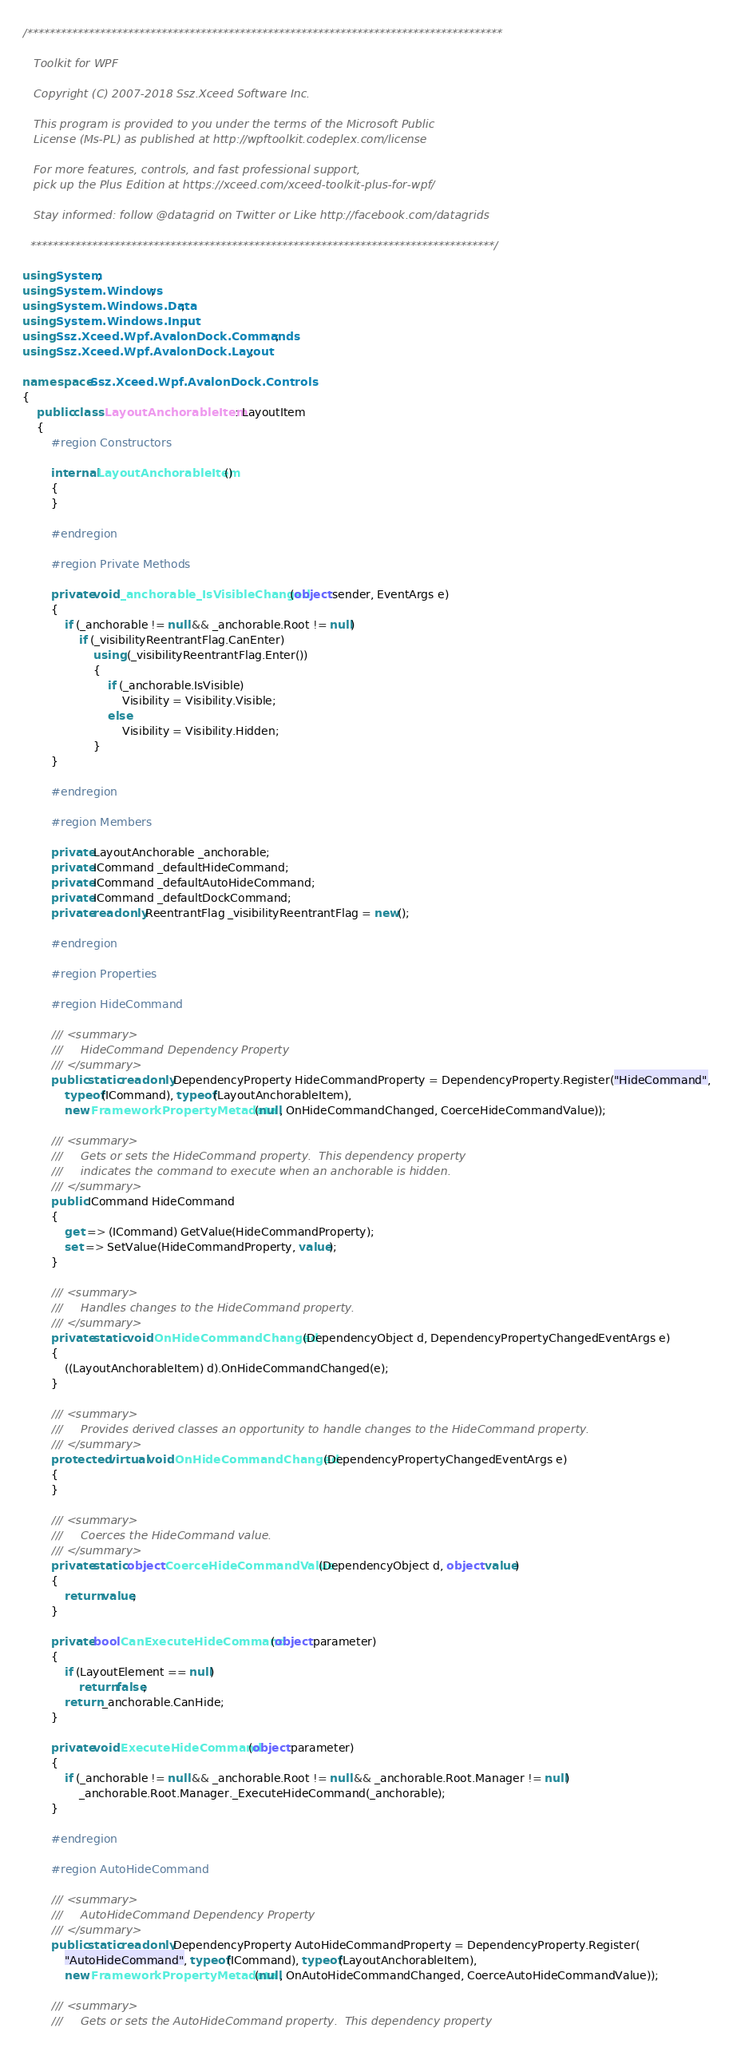Convert code to text. <code><loc_0><loc_0><loc_500><loc_500><_C#_>/*************************************************************************************
   
   Toolkit for WPF

   Copyright (C) 2007-2018 Ssz.Xceed Software Inc.

   This program is provided to you under the terms of the Microsoft Public
   License (Ms-PL) as published at http://wpftoolkit.codeplex.com/license 

   For more features, controls, and fast professional support,
   pick up the Plus Edition at https://xceed.com/xceed-toolkit-plus-for-wpf/

   Stay informed: follow @datagrid on Twitter or Like http://facebook.com/datagrids

  ***********************************************************************************/

using System;
using System.Windows;
using System.Windows.Data;
using System.Windows.Input;
using Ssz.Xceed.Wpf.AvalonDock.Commands;
using Ssz.Xceed.Wpf.AvalonDock.Layout;

namespace Ssz.Xceed.Wpf.AvalonDock.Controls
{
    public class LayoutAnchorableItem : LayoutItem
    {
        #region Constructors

        internal LayoutAnchorableItem()
        {
        }

        #endregion

        #region Private Methods

        private void _anchorable_IsVisibleChanged(object sender, EventArgs e)
        {
            if (_anchorable != null && _anchorable.Root != null)
                if (_visibilityReentrantFlag.CanEnter)
                    using (_visibilityReentrantFlag.Enter())
                    {
                        if (_anchorable.IsVisible)
                            Visibility = Visibility.Visible;
                        else
                            Visibility = Visibility.Hidden;
                    }
        }

        #endregion

        #region Members

        private LayoutAnchorable _anchorable;
        private ICommand _defaultHideCommand;
        private ICommand _defaultAutoHideCommand;
        private ICommand _defaultDockCommand;
        private readonly ReentrantFlag _visibilityReentrantFlag = new();

        #endregion

        #region Properties

        #region HideCommand

        /// <summary>
        ///     HideCommand Dependency Property
        /// </summary>
        public static readonly DependencyProperty HideCommandProperty = DependencyProperty.Register("HideCommand",
            typeof(ICommand), typeof(LayoutAnchorableItem),
            new FrameworkPropertyMetadata(null, OnHideCommandChanged, CoerceHideCommandValue));

        /// <summary>
        ///     Gets or sets the HideCommand property.  This dependency property
        ///     indicates the command to execute when an anchorable is hidden.
        /// </summary>
        public ICommand HideCommand
        {
            get => (ICommand) GetValue(HideCommandProperty);
            set => SetValue(HideCommandProperty, value);
        }

        /// <summary>
        ///     Handles changes to the HideCommand property.
        /// </summary>
        private static void OnHideCommandChanged(DependencyObject d, DependencyPropertyChangedEventArgs e)
        {
            ((LayoutAnchorableItem) d).OnHideCommandChanged(e);
        }

        /// <summary>
        ///     Provides derived classes an opportunity to handle changes to the HideCommand property.
        /// </summary>
        protected virtual void OnHideCommandChanged(DependencyPropertyChangedEventArgs e)
        {
        }

        /// <summary>
        ///     Coerces the HideCommand value.
        /// </summary>
        private static object CoerceHideCommandValue(DependencyObject d, object value)
        {
            return value;
        }

        private bool CanExecuteHideCommand(object parameter)
        {
            if (LayoutElement == null)
                return false;
            return _anchorable.CanHide;
        }

        private void ExecuteHideCommand(object parameter)
        {
            if (_anchorable != null && _anchorable.Root != null && _anchorable.Root.Manager != null)
                _anchorable.Root.Manager._ExecuteHideCommand(_anchorable);
        }

        #endregion

        #region AutoHideCommand

        /// <summary>
        ///     AutoHideCommand Dependency Property
        /// </summary>
        public static readonly DependencyProperty AutoHideCommandProperty = DependencyProperty.Register(
            "AutoHideCommand", typeof(ICommand), typeof(LayoutAnchorableItem),
            new FrameworkPropertyMetadata(null, OnAutoHideCommandChanged, CoerceAutoHideCommandValue));

        /// <summary>
        ///     Gets or sets the AutoHideCommand property.  This dependency property</code> 